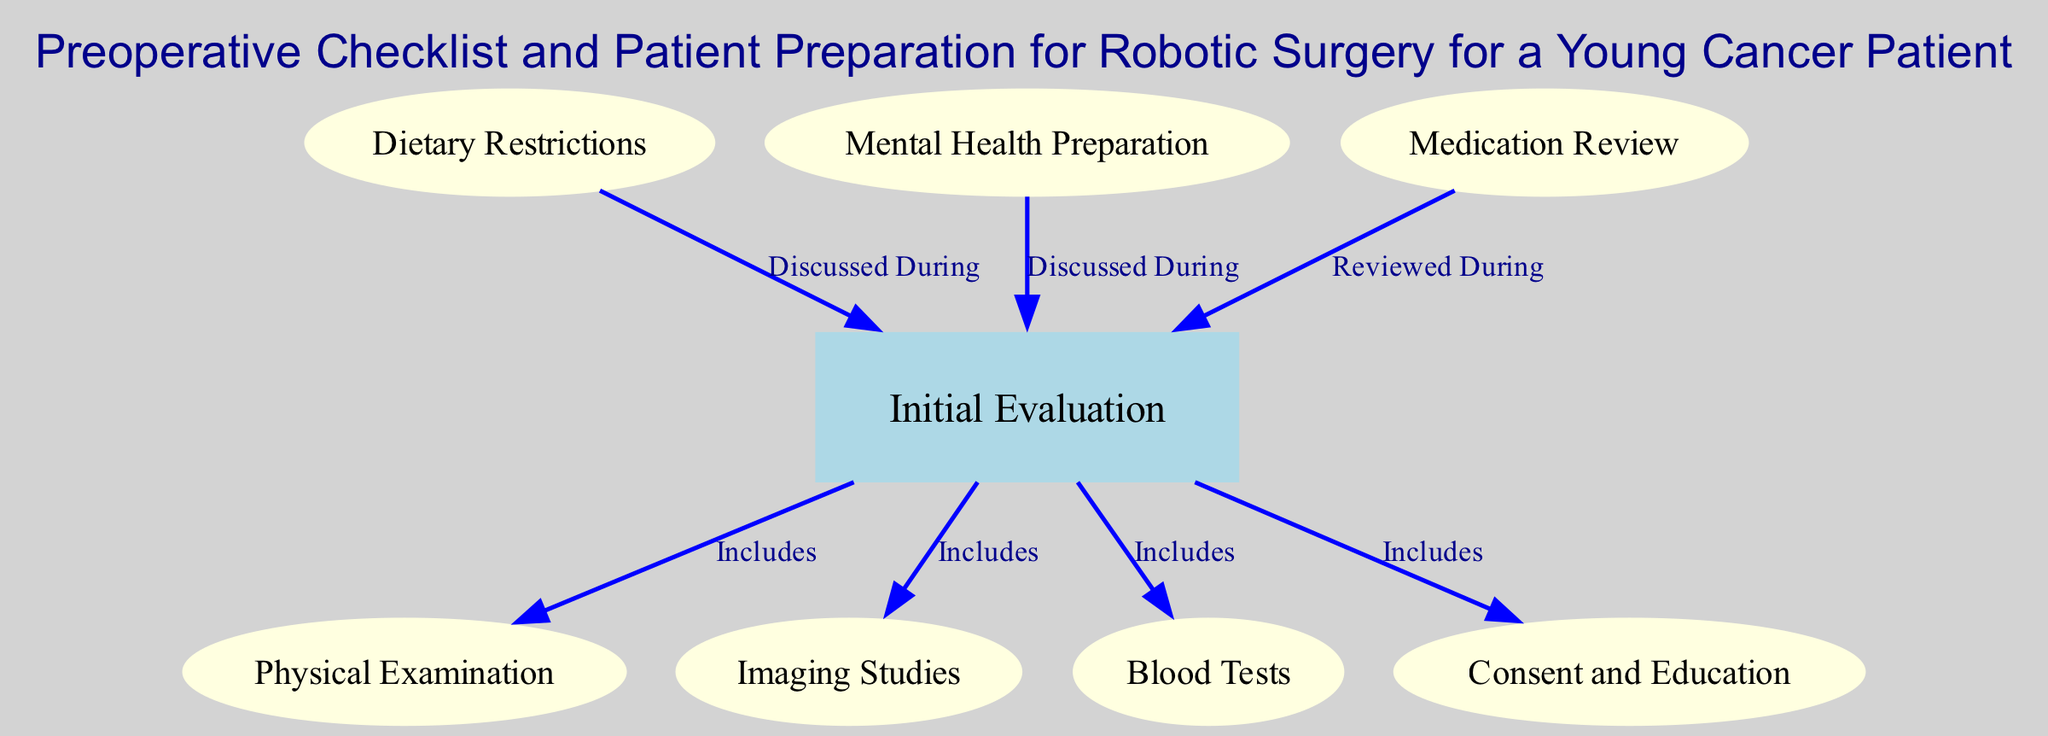What is the primary focus of the diagram? The diagram centers on the preoperative checklist and patient preparation steps for robotic surgery, specifically aimed at young cancer patients.
Answer: Preoperative checklist and patient preparation for robotic surgery How many total nodes are present in the diagram? To find the number of nodes, we count each unique node listed in the diagram data. There are 8 nodes in total: Initial Evaluation, Physical Examination, Imaging Studies, Blood Tests, Dietary Restrictions, Mental Health Preparation, Consent and Education, Medication Review.
Answer: 8 Which node is highlighted as the main step in the procedure? The main step is indicated by a rectangular node known as "Initial Evaluation," which forms the central part of the preparation process.
Answer: Initial Evaluation What type of relationship connects "Dietary Restrictions" and "Initial Evaluation"? The relationship is labeled as "Discussed During," indicating that dietary restrictions are topics covered within the initial evaluation process.
Answer: Discussed During What evaluations are included under "Initial Evaluation"? The evaluations listed under "Initial Evaluation" include Physical Examination, Imaging Studies, Blood Tests, and Consent and Education, all specified as included components.
Answer: Physical Examination, Imaging Studies, Blood Tests, Consent and Education Which two nodes are specifically about mental health considerations? The two nodes focused on mental health considerations are "Mental Health Preparation" and "Initial Evaluation," the latter indicating that mental health topics are discussed during initial evaluation.
Answer: Mental Health Preparation, Initial Evaluation Which node requires a review of medications? The node titled "Medication Review" indicates that a review of medications is a necessary step in the preparation process.
Answer: Medication Review How many edges are leading from the "Initial Evaluation" node? The diagram shows four edges leading from the "Initial Evaluation" node, indicating its connections to Physical Examination, Imaging Studies, Blood Tests, and Consent and Education.
Answer: 4 What is a critical consideration mentioned alongside evaluations in the preparation process? "Mental Health Preparation" is noted as a critical consideration that is integrated into the overall evaluation process for the young cancer patient preparing for surgery.
Answer: Mental Health Preparation 